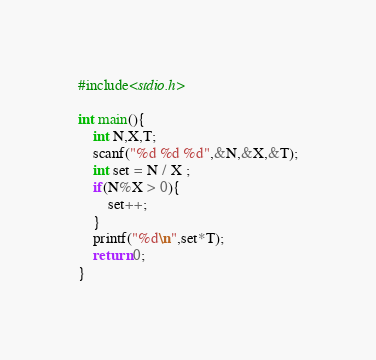Convert code to text. <code><loc_0><loc_0><loc_500><loc_500><_C_>#include<stdio.h>

int main(){
    int N,X,T;
    scanf("%d %d %d",&N,&X,&T);
    int set = N / X ;
    if(N%X > 0){
        set++;
    }
    printf("%d\n",set*T);
    return 0;
}</code> 